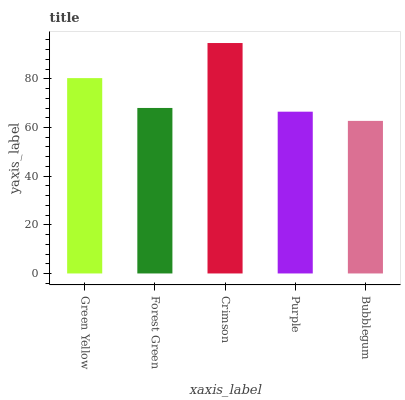Is Bubblegum the minimum?
Answer yes or no. Yes. Is Crimson the maximum?
Answer yes or no. Yes. Is Forest Green the minimum?
Answer yes or no. No. Is Forest Green the maximum?
Answer yes or no. No. Is Green Yellow greater than Forest Green?
Answer yes or no. Yes. Is Forest Green less than Green Yellow?
Answer yes or no. Yes. Is Forest Green greater than Green Yellow?
Answer yes or no. No. Is Green Yellow less than Forest Green?
Answer yes or no. No. Is Forest Green the high median?
Answer yes or no. Yes. Is Forest Green the low median?
Answer yes or no. Yes. Is Purple the high median?
Answer yes or no. No. Is Green Yellow the low median?
Answer yes or no. No. 